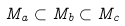Convert formula to latex. <formula><loc_0><loc_0><loc_500><loc_500>M _ { a } \subset M _ { b } \subset M _ { c }</formula> 